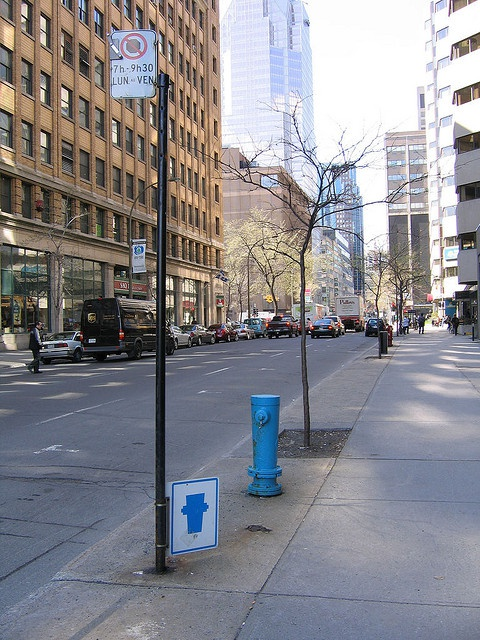Describe the objects in this image and their specific colors. I can see truck in gray, black, and darkgray tones, fire hydrant in gray, blue, and navy tones, car in gray, black, and darkgray tones, truck in gray, darkgray, black, and maroon tones, and truck in gray, black, and darkgray tones in this image. 